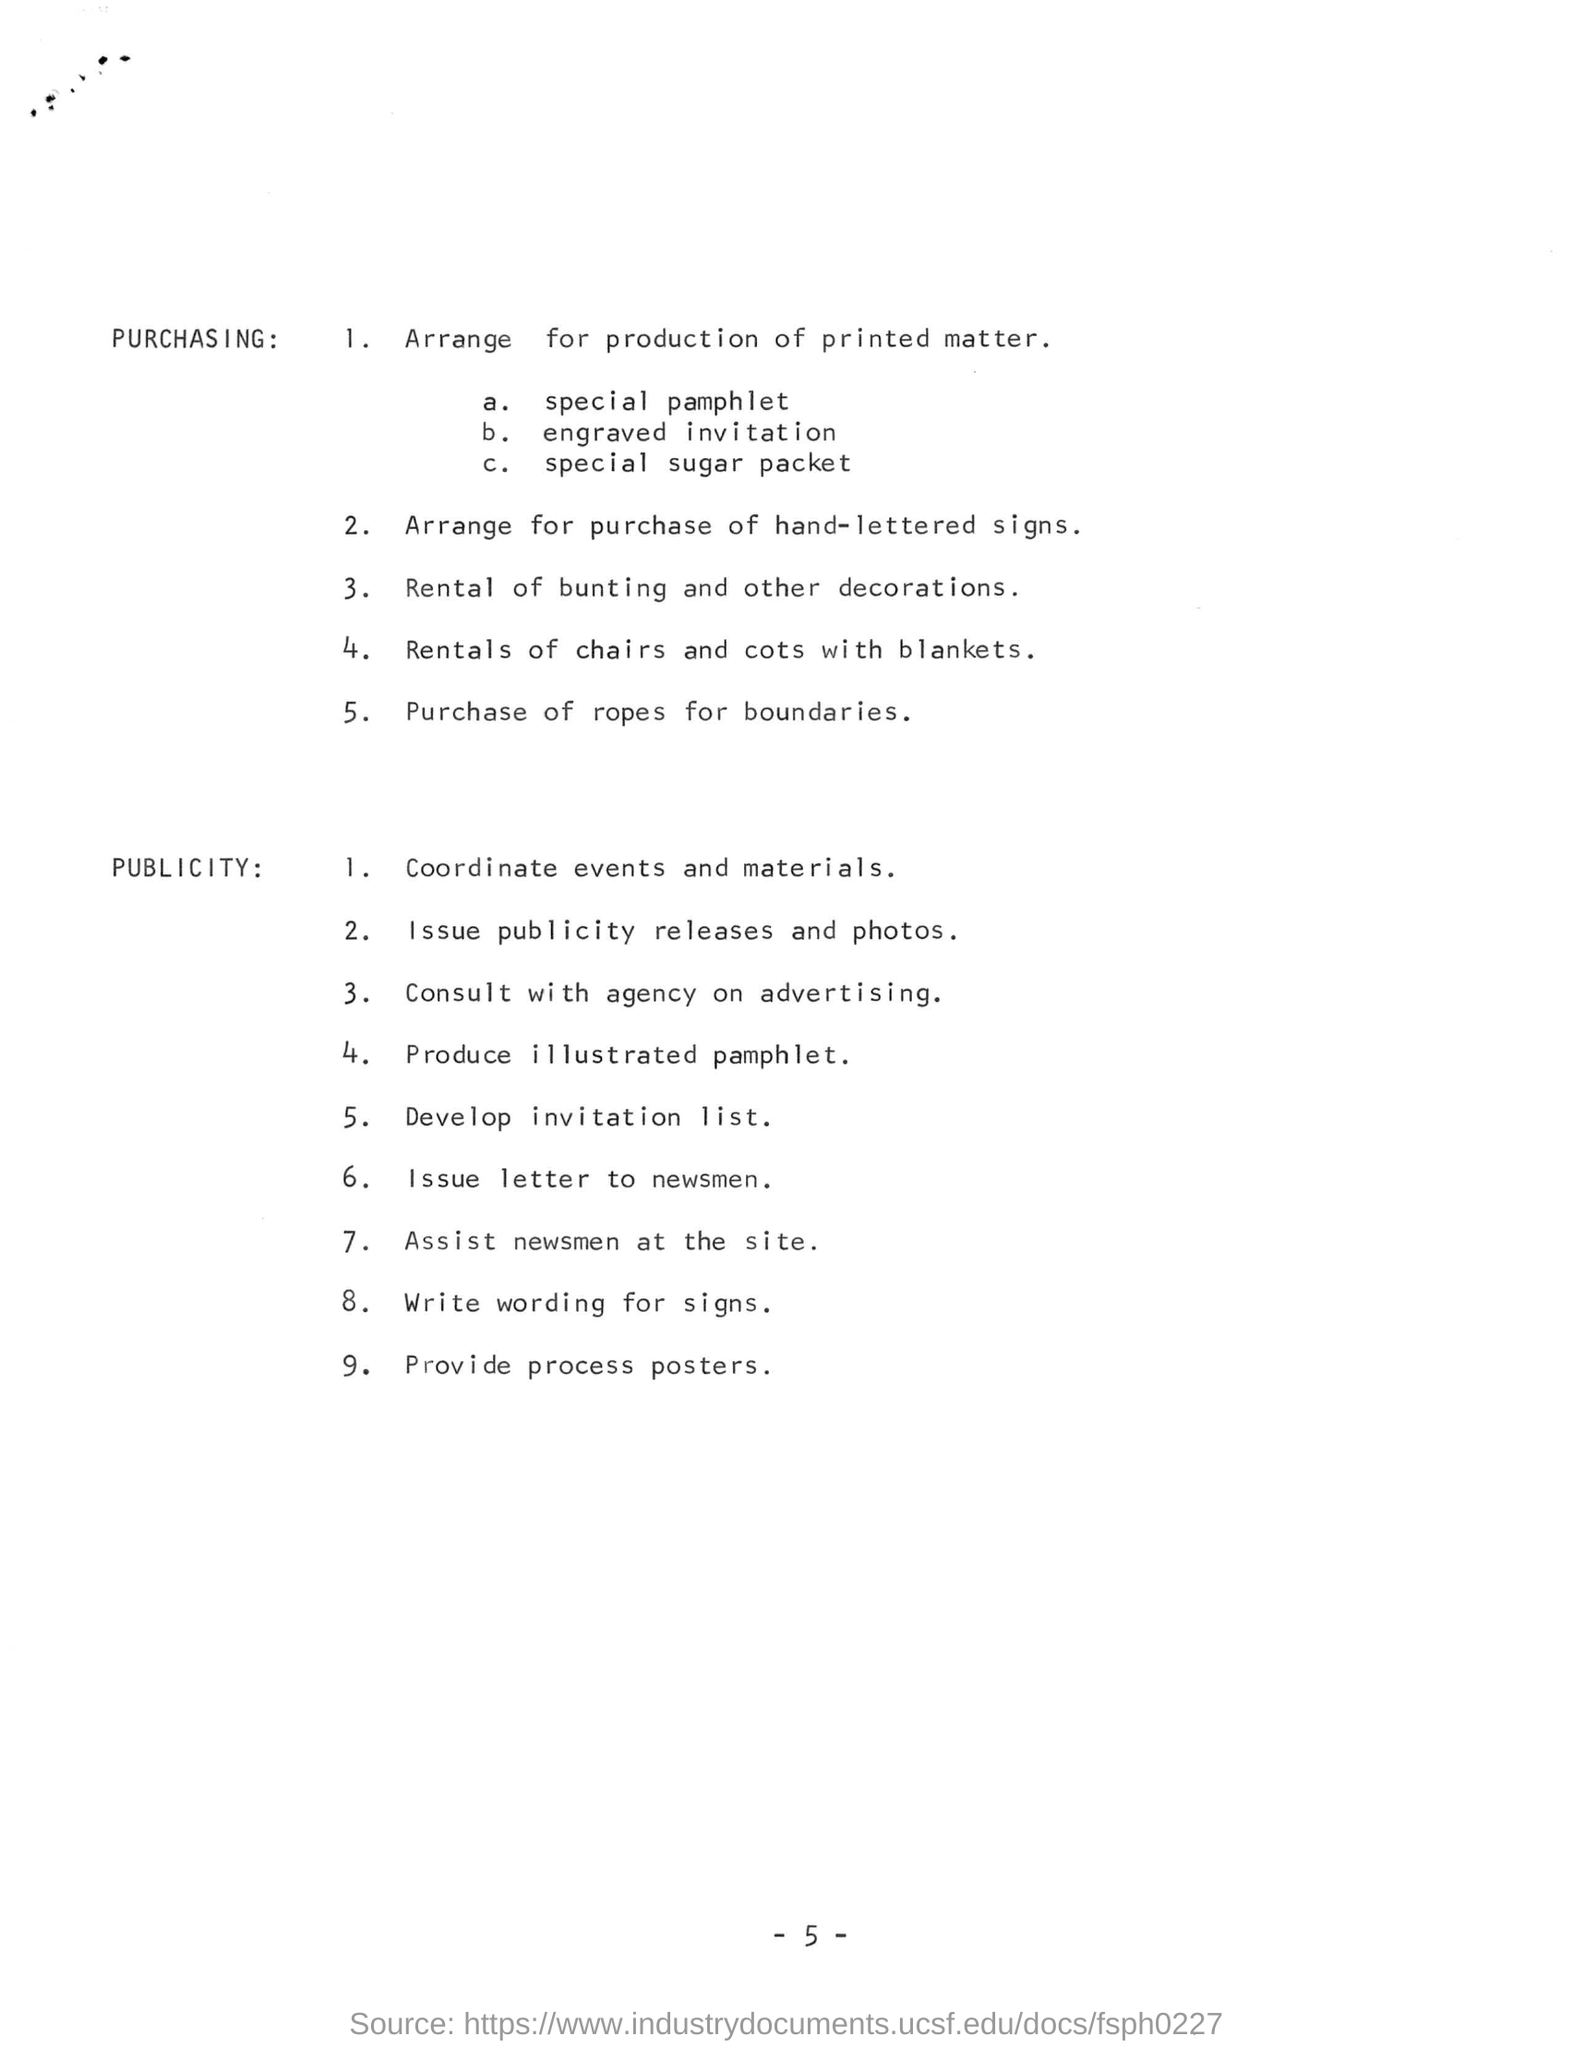Outline some significant characteristics in this image. There are a total of nine points listed under the category of publicity. Consultation with an agency is intended solely for the purpose of advertising. The process for determining which posters are to be provided will be discussed. 